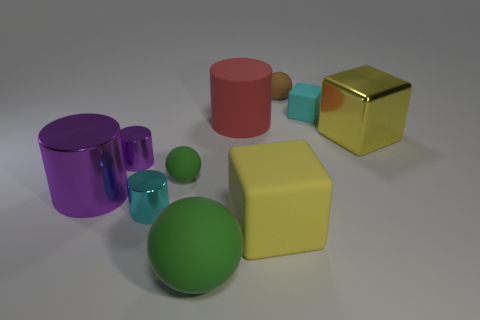Can you tell me the different colors present in the image? Certainly! The image displays a multitude of colors, including purple, red, brown, teal, green, yellow, and gold. These colors add a vibrant diversity to the assortment of objects. 